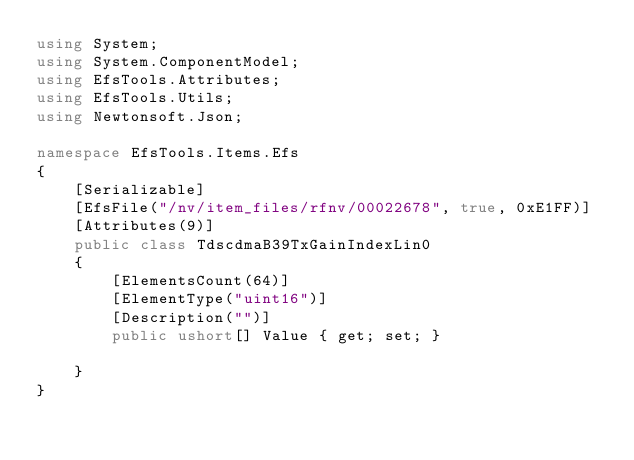Convert code to text. <code><loc_0><loc_0><loc_500><loc_500><_C#_>using System;
using System.ComponentModel;
using EfsTools.Attributes;
using EfsTools.Utils;
using Newtonsoft.Json;

namespace EfsTools.Items.Efs
{
    [Serializable]
    [EfsFile("/nv/item_files/rfnv/00022678", true, 0xE1FF)]
    [Attributes(9)]
    public class TdscdmaB39TxGainIndexLin0
    {
        [ElementsCount(64)]
        [ElementType("uint16")]
        [Description("")]
        public ushort[] Value { get; set; }
        
    }
}
</code> 